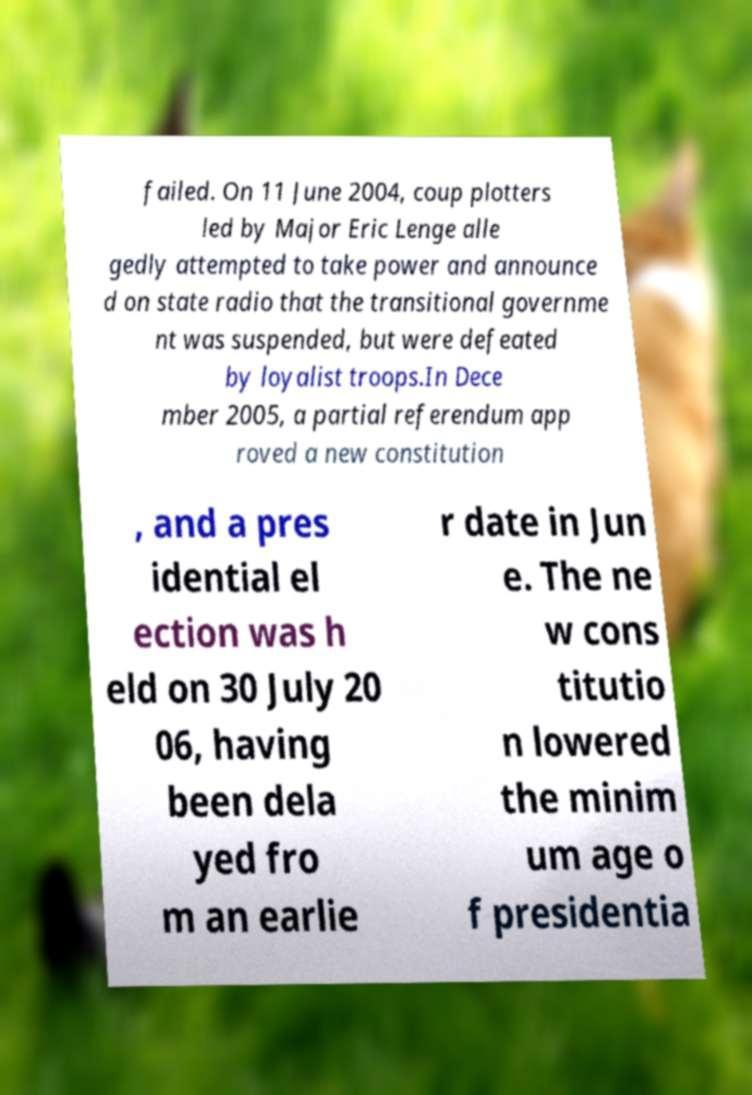Please identify and transcribe the text found in this image. failed. On 11 June 2004, coup plotters led by Major Eric Lenge alle gedly attempted to take power and announce d on state radio that the transitional governme nt was suspended, but were defeated by loyalist troops.In Dece mber 2005, a partial referendum app roved a new constitution , and a pres idential el ection was h eld on 30 July 20 06, having been dela yed fro m an earlie r date in Jun e. The ne w cons titutio n lowered the minim um age o f presidentia 